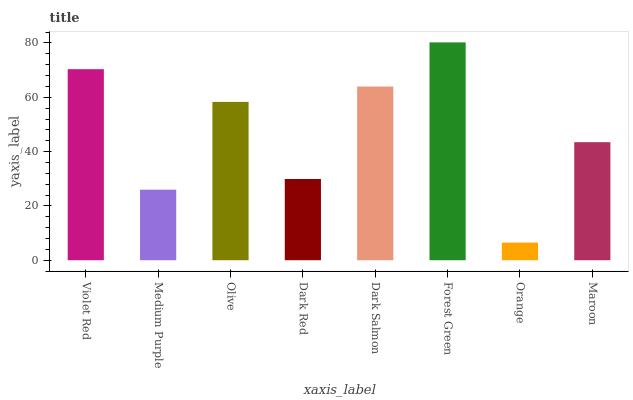Is Orange the minimum?
Answer yes or no. Yes. Is Forest Green the maximum?
Answer yes or no. Yes. Is Medium Purple the minimum?
Answer yes or no. No. Is Medium Purple the maximum?
Answer yes or no. No. Is Violet Red greater than Medium Purple?
Answer yes or no. Yes. Is Medium Purple less than Violet Red?
Answer yes or no. Yes. Is Medium Purple greater than Violet Red?
Answer yes or no. No. Is Violet Red less than Medium Purple?
Answer yes or no. No. Is Olive the high median?
Answer yes or no. Yes. Is Maroon the low median?
Answer yes or no. Yes. Is Medium Purple the high median?
Answer yes or no. No. Is Forest Green the low median?
Answer yes or no. No. 